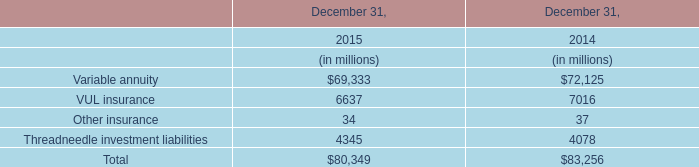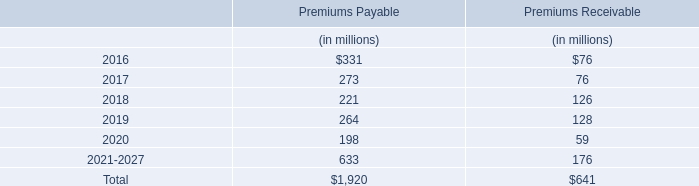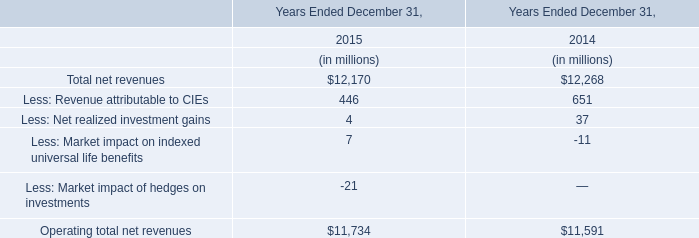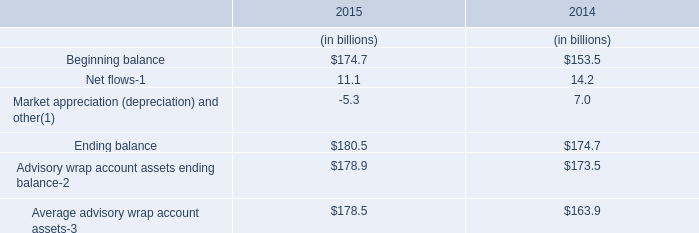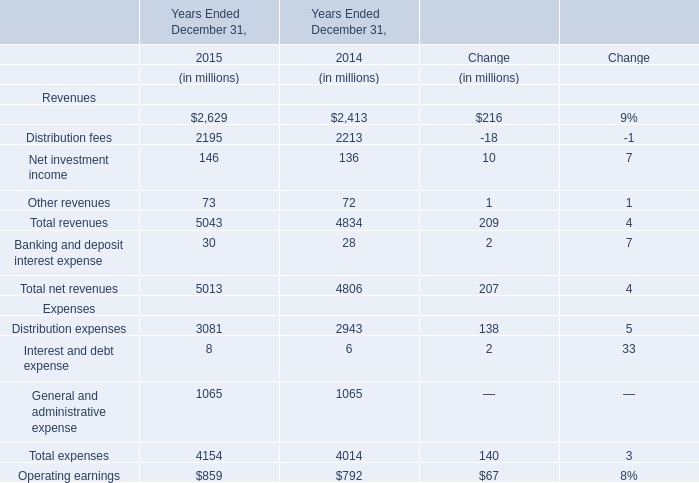In the year with the most Management and financial advice fees in table 4, what is the growth rate of Distribution fees in table 4? 
Computations: ((2195 - 2213) / 2213)
Answer: -0.00813. 